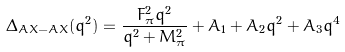<formula> <loc_0><loc_0><loc_500><loc_500>\Delta _ { A X - A X } ( q ^ { 2 } ) = \frac { F _ { \pi } ^ { 2 } q ^ { 2 } } { q ^ { 2 } + M _ { \pi } ^ { 2 } } + A _ { 1 } + A _ { 2 } q ^ { 2 } + A _ { 3 } q ^ { 4 }</formula> 